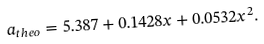<formula> <loc_0><loc_0><loc_500><loc_500>a _ { t h e o } = 5 . 3 8 7 + 0 . 1 4 2 8 x + 0 . 0 5 3 2 x ^ { 2 } .</formula> 